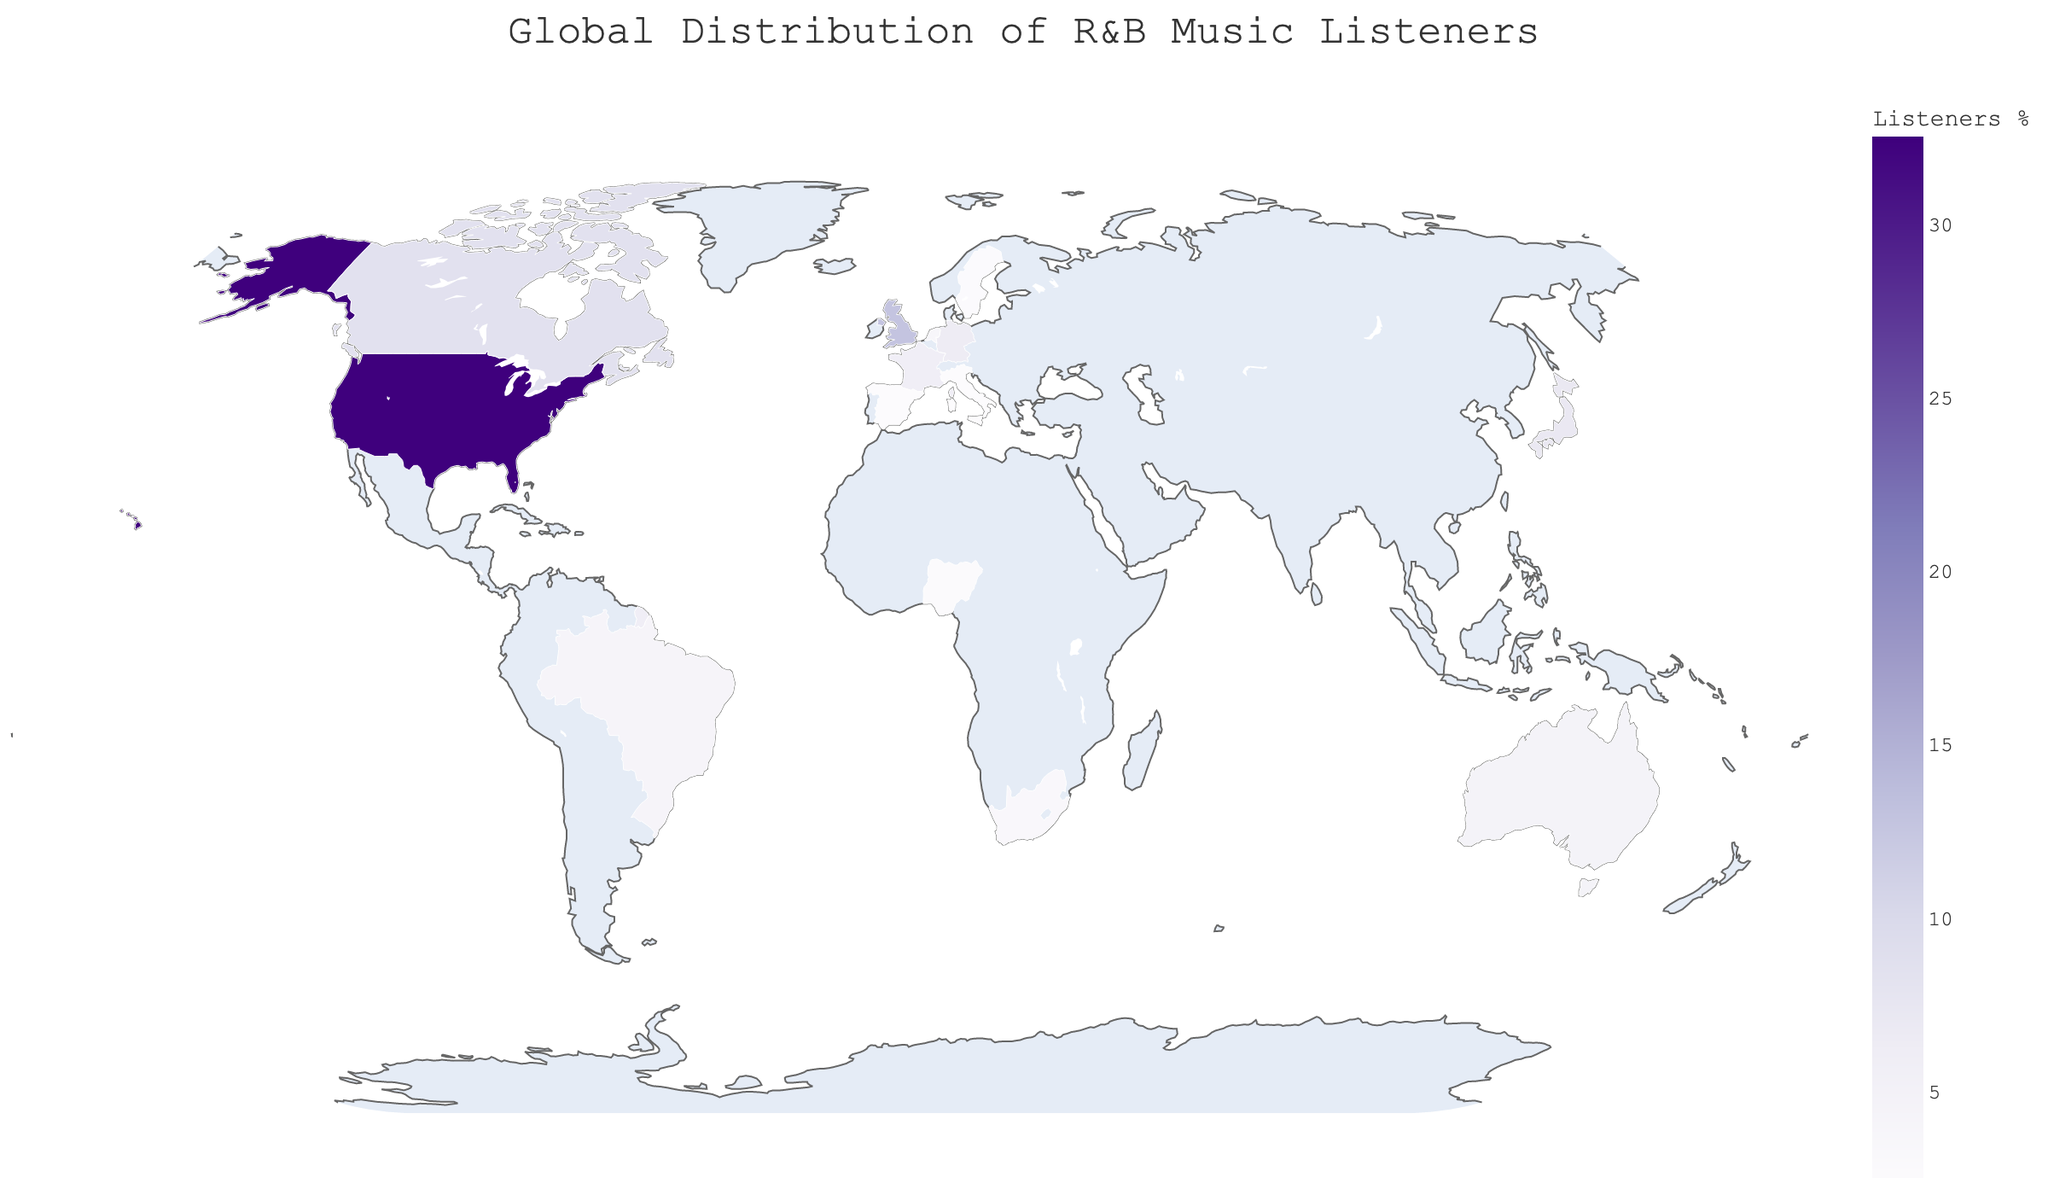What is the percentage of R&B music listeners in the United States? The figure shows countries and their corresponding percentages of R&B listeners. The percentage for the United States is directly visible.
Answer: 32.5% Which country has the lowest percentage of R&B music listeners? By examining the figure, we can identify the country with the smallest percentage of listeners. The country with the lowest percentage is Spain.
Answer: Spain How many streaming hours in millions are there collectively for France and Germany? Look at the individual streaming hours for France and Germany in the figure. France has 225 million hours, and Germany has 250 million hours. Summing these values gives 225 + 250 = 475 million hours.
Answer: 475 million Which country has a higher percentage of R&B music listeners, Canada or Australia? Compare the percentages of R&B listeners shown for Canada and Australia. Canada has 8.6%, and Australia has 4.7%.
Answer: Canada What is the total percentage of listeners for the top three countries? Determine the top three countries by their listener percentages. The top three are the United States (32.5%), the United Kingdom (12.8%), and Canada (8.6%). Sum these percentages: 32.5 + 12.8 + 8.6 = 53.9%.
Answer: 53.9% How does Brazil's percentage of listeners compare to Sweden's? Examine the listener percentages of both Brazil and Sweden from the figure. Brazil has 4.3% and Sweden has 2.7%. Brazil's percentage is greater.
Answer: Brazil What is the average percentage of R&B music listeners among the listed European countries? Identify the European countries: the United Kingdom (12.8%), Germany (6.5%), France (5.9%), the Netherlands (3.8%), Sweden (2.7%), Italy (2.6%), and Spain (2.5%). Sum these percentages and divide by the number of countries: (12.8 + 6.5 + 5.9 + 3.8 + 2.7 + 2.6 + 2.5) / 7 = 5.3957 (approx. 5.4%).
Answer: 5.4% Which country has fewer streaming hours, Nigeria or South Africa? By checking the streaming hours for both countries: Nigeria has 110 million, and South Africa has 135 million. Nigeria has fewer streaming hours.
Answer: Nigeria What is the title of the figure? The title is prominently displayed at the top of the figure.
Answer: Global Distribution of R&B Music Listeners What color scale is used in the geographic plot? Observe the color gradient on the figure, which ranges through shades of purple. The color scale used is `Purples`.
Answer: Purples 